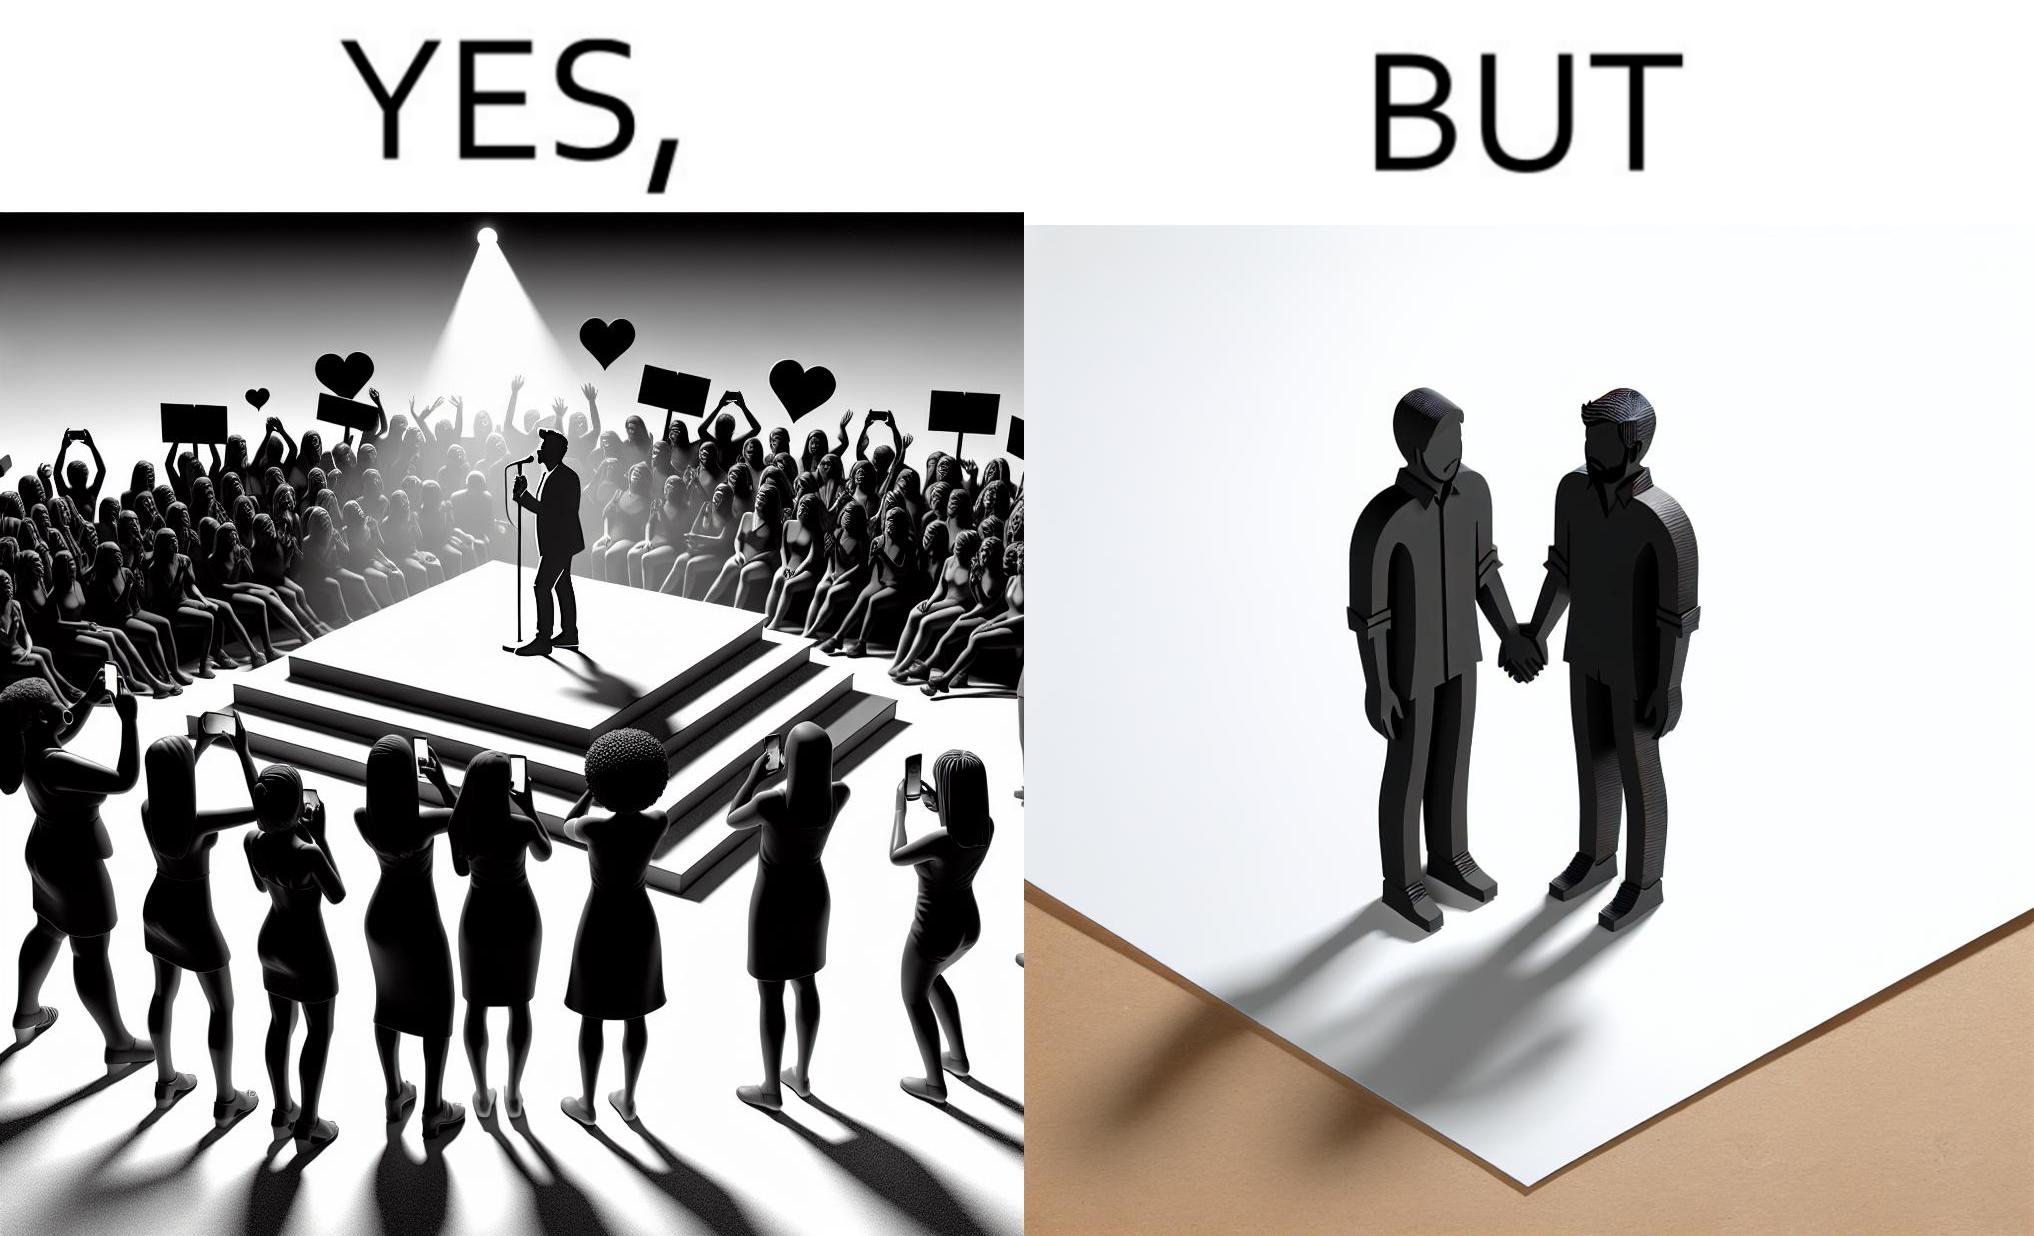What do you see in each half of this image? In the left part of the image: The person shows a man singing on a platform under a spotlight. There are several girls around the platform enjoying his singing and cheering for him. A few girls are taking his photos using their phone and a few also have a poster with heart drawn on it. In the right part of the image: The image shows two men holding hands. 